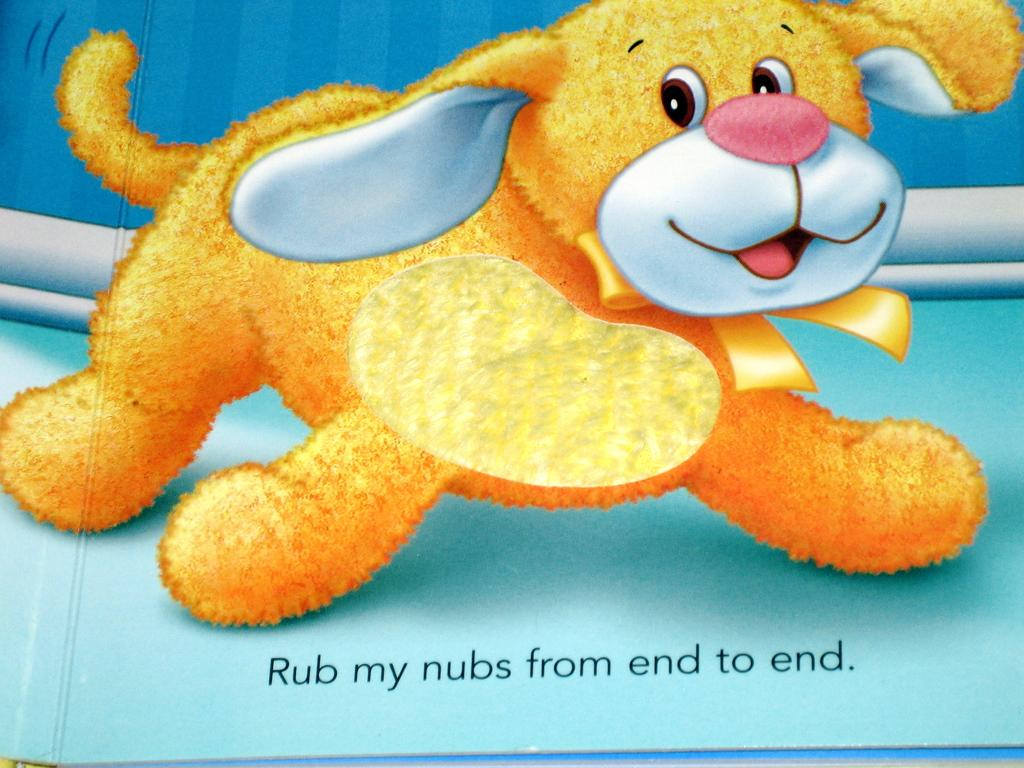What is the main subject of the image? There is a depiction of a dog in the image. What else can be seen in the image besides the dog? There is text written in the image. What color is the surface in the image? The surface in the image is blue. How would you describe the background of the image? The background of the image includes white and blue colors. What type of growth can be seen on the dog's elbow in the image? There is no dog's elbow present in the image, as it is a depiction of a dog and not a photograph. 